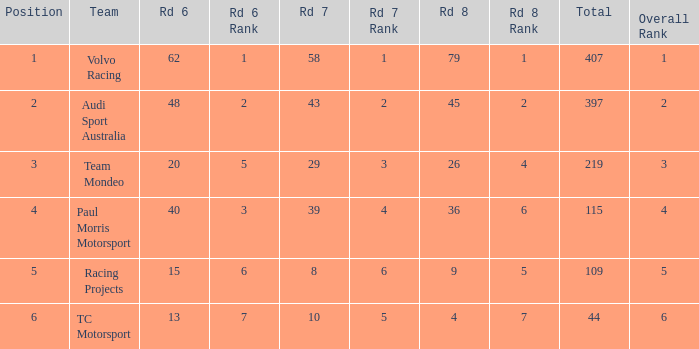What is the average value for Rd 8 in a position less than 2 for Audi Sport Australia? None. 